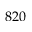Convert formula to latex. <formula><loc_0><loc_0><loc_500><loc_500>8 2 0</formula> 